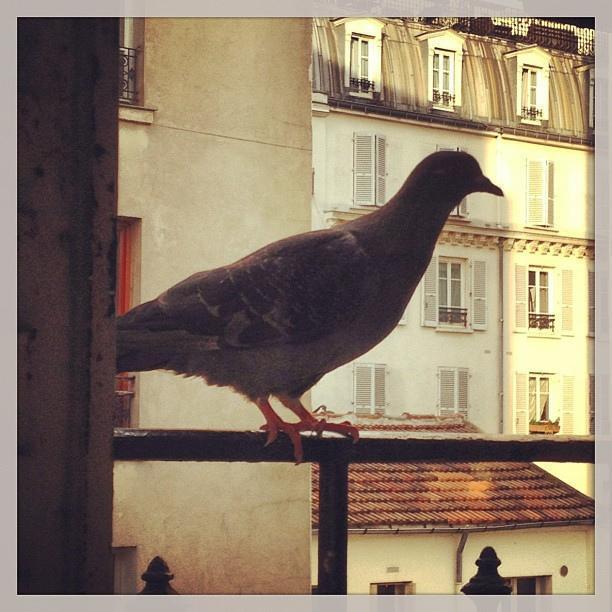How many birds can you see?
Give a very brief answer. 1. How many people are wearing a black shirt?
Give a very brief answer. 0. 